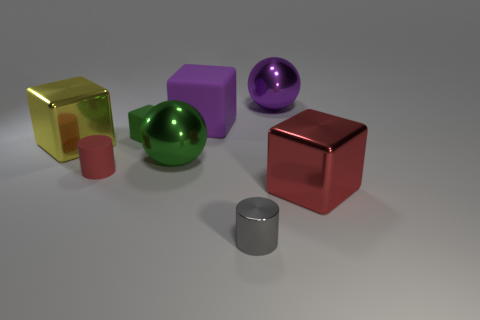The big rubber object that is the same shape as the tiny green object is what color?
Your response must be concise. Purple. Is the gray metallic thing the same size as the purple cube?
Provide a succinct answer. No. Is the number of tiny cylinders behind the big purple metal ball the same as the number of big red cubes to the left of the large green metal object?
Ensure brevity in your answer.  Yes. Are any tiny rubber blocks visible?
Your answer should be compact. Yes. There is a yellow metallic thing that is the same shape as the large purple rubber object; what size is it?
Keep it short and to the point. Large. There is a matte cube in front of the large purple matte object; what size is it?
Provide a succinct answer. Small. Are there more red objects behind the metallic cylinder than big yellow metallic things?
Your answer should be compact. Yes. The small green object is what shape?
Your answer should be compact. Cube. There is a cylinder in front of the big red metallic object; is it the same color as the large block that is to the right of the tiny gray metallic thing?
Your answer should be very brief. No. Does the small red rubber object have the same shape as the large red thing?
Give a very brief answer. No. 